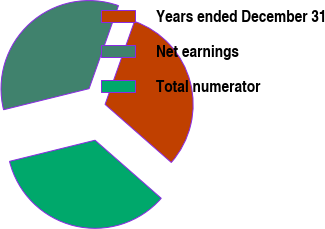<chart> <loc_0><loc_0><loc_500><loc_500><pie_chart><fcel>Years ended December 31<fcel>Net earnings<fcel>Total numerator<nl><fcel>31.04%<fcel>34.27%<fcel>34.69%<nl></chart> 